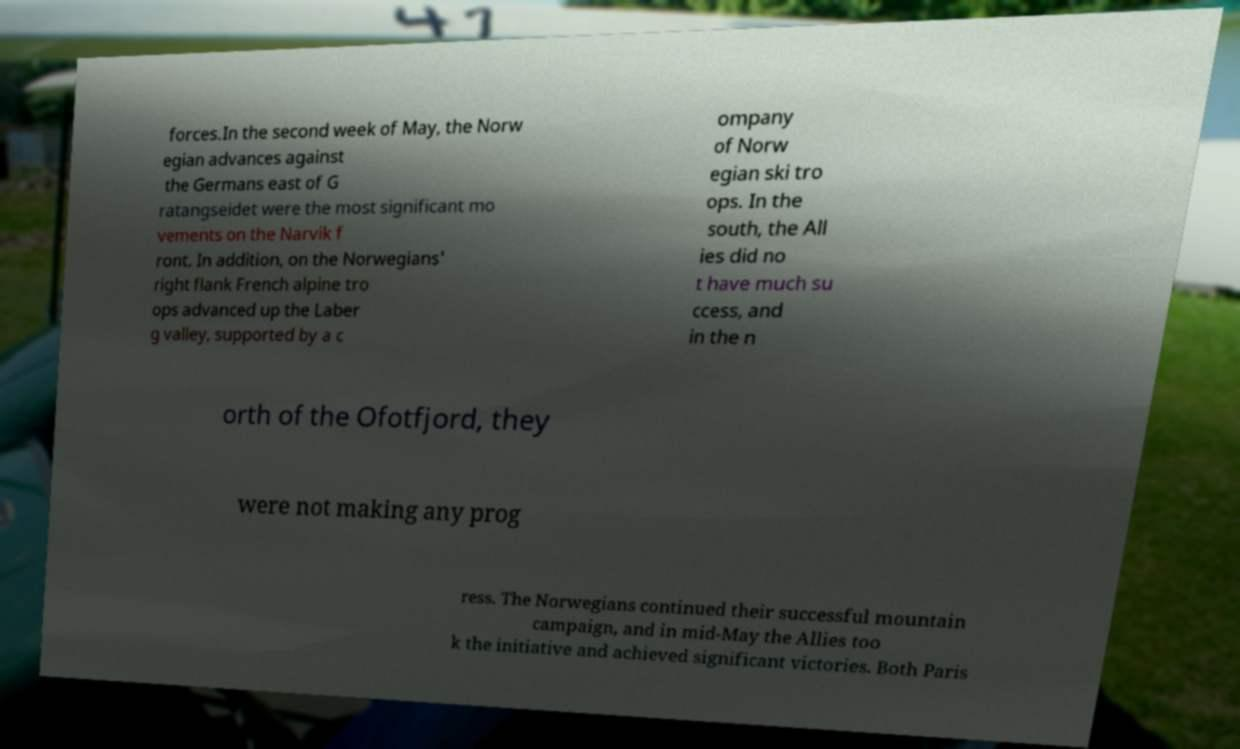I need the written content from this picture converted into text. Can you do that? forces.In the second week of May, the Norw egian advances against the Germans east of G ratangseidet were the most significant mo vements on the Narvik f ront. In addition, on the Norwegians' right flank French alpine tro ops advanced up the Laber g valley, supported by a c ompany of Norw egian ski tro ops. In the south, the All ies did no t have much su ccess, and in the n orth of the Ofotfjord, they were not making any prog ress. The Norwegians continued their successful mountain campaign, and in mid-May the Allies too k the initiative and achieved significant victories. Both Paris 